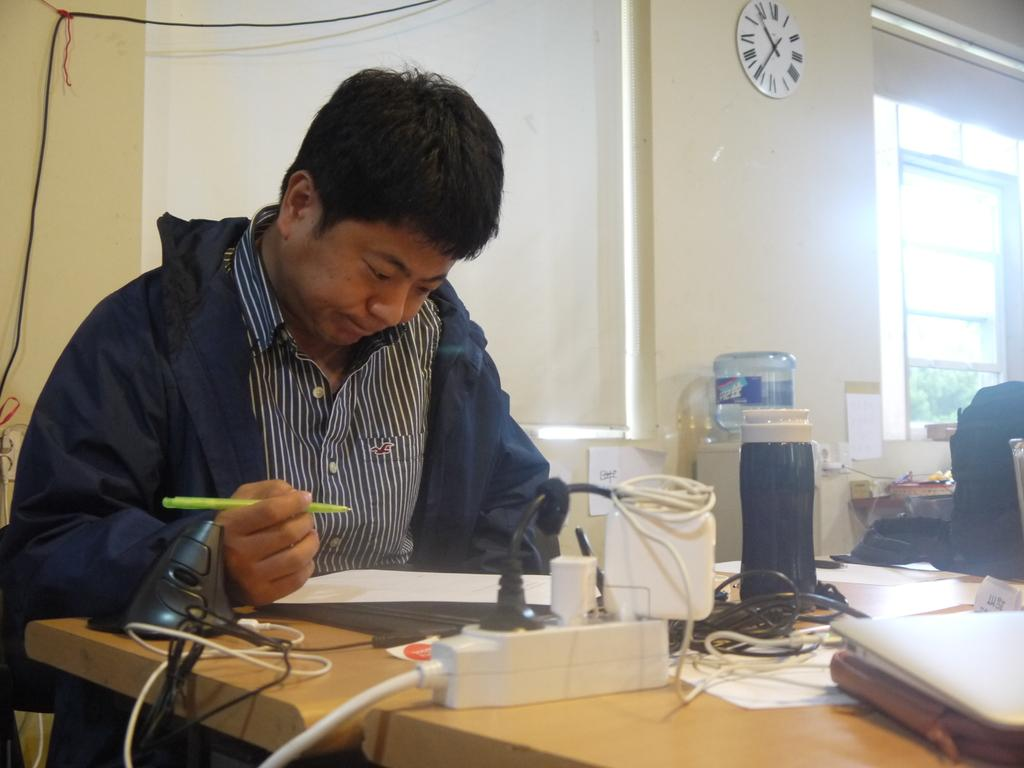What is the man in the image doing? The man is seated and writing with a pen. What objects are on the table in the image? There are papers, a laptop, and books on the table. What is the man using to write? The man is using a pen to write. What can be seen inside the water bottle in the image? There is water visible in the water bottle. What time-telling device is present in the image? There is a wall clock on the wall. Are there any dinosaurs visible in the image? No, there are no dinosaurs present in the image. What type of motion is the unit in the image performing? There is no unit or motion mentioned in the image; it only features a man writing, objects on a table, and a wall clock. 